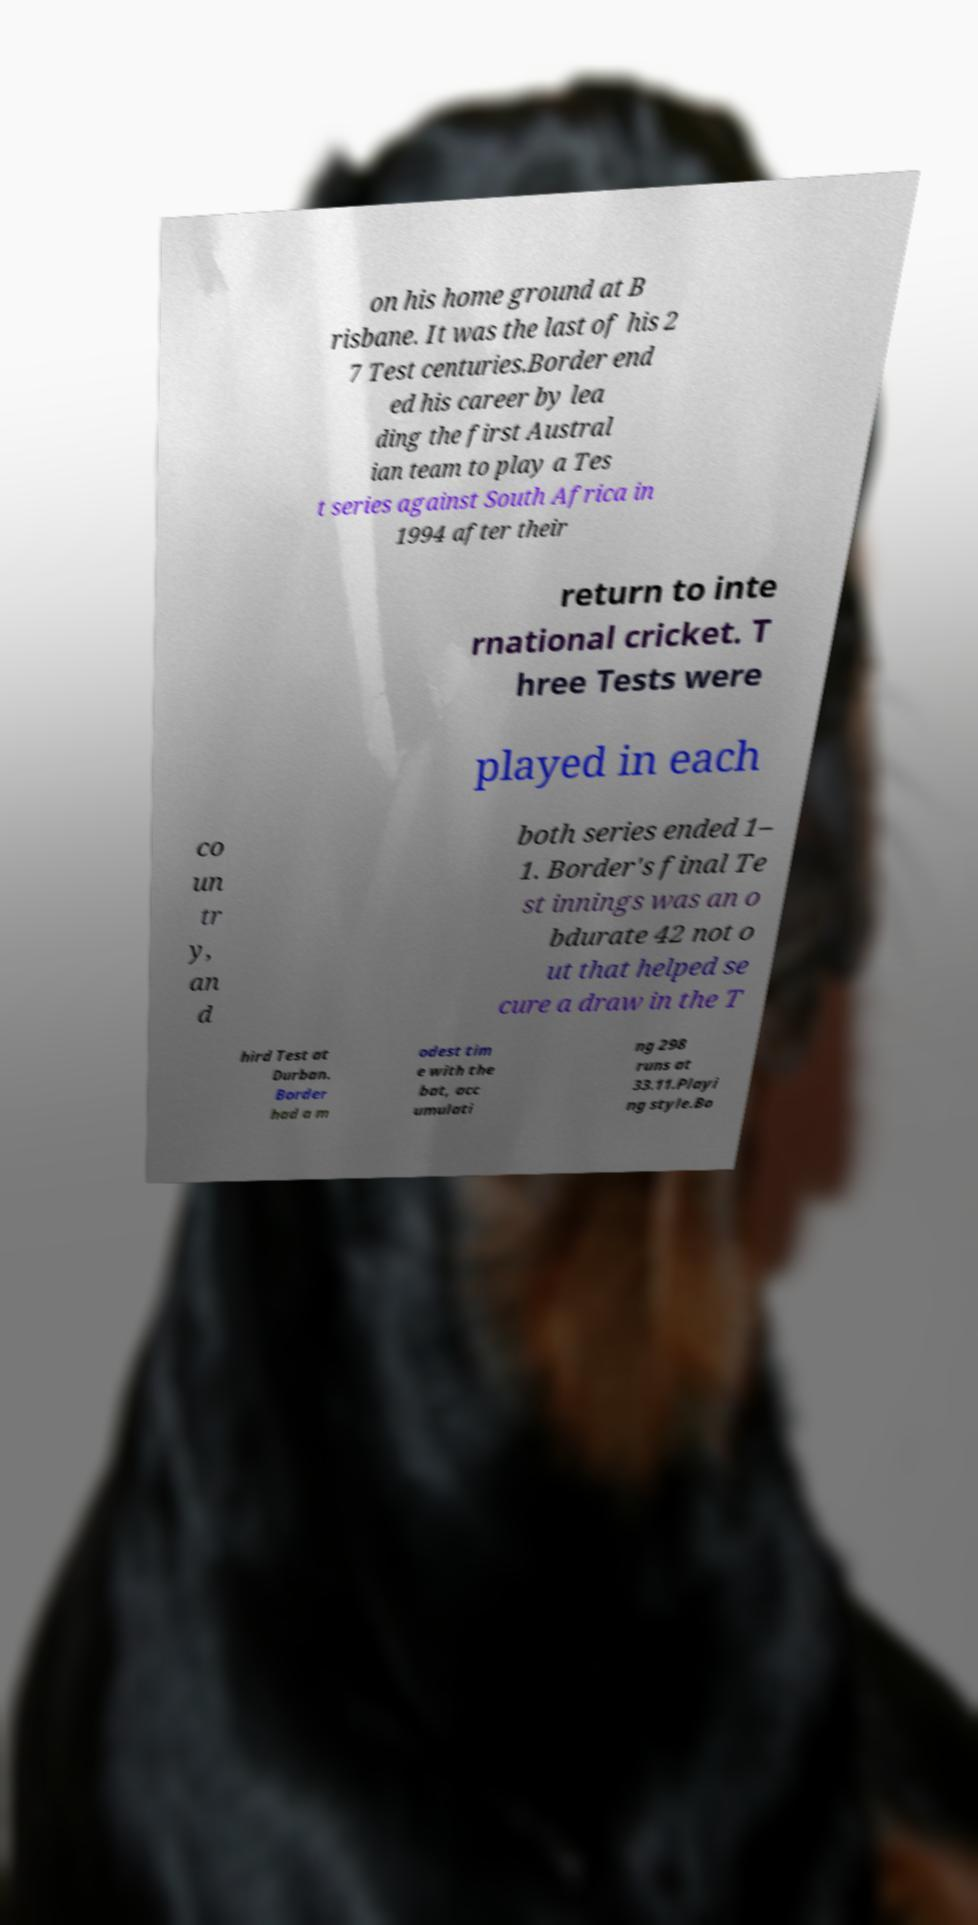Please identify and transcribe the text found in this image. on his home ground at B risbane. It was the last of his 2 7 Test centuries.Border end ed his career by lea ding the first Austral ian team to play a Tes t series against South Africa in 1994 after their return to inte rnational cricket. T hree Tests were played in each co un tr y, an d both series ended 1– 1. Border's final Te st innings was an o bdurate 42 not o ut that helped se cure a draw in the T hird Test at Durban. Border had a m odest tim e with the bat, acc umulati ng 298 runs at 33.11.Playi ng style.Bo 